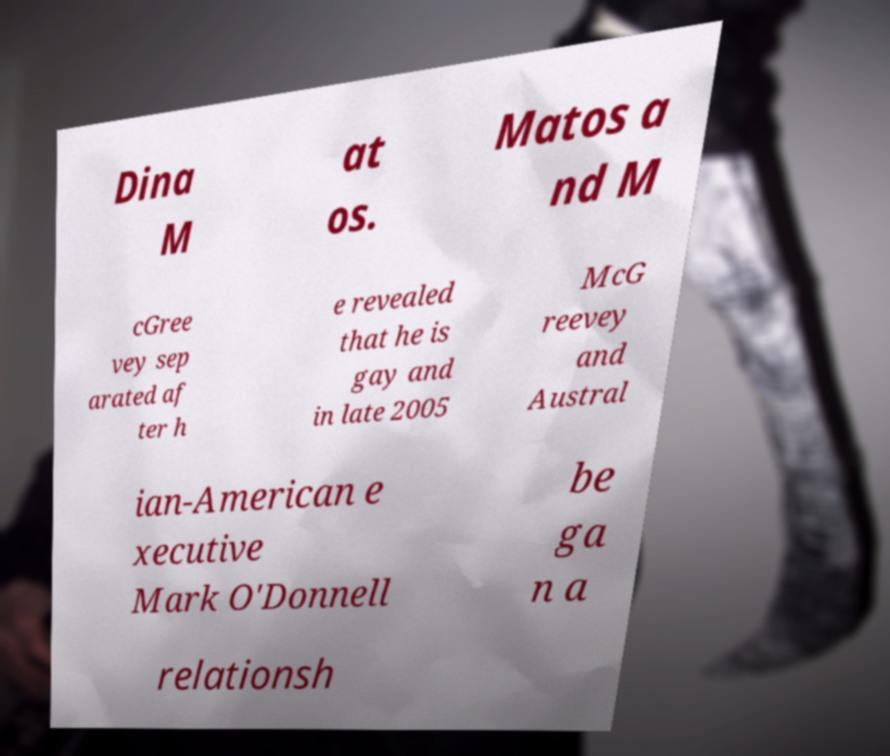Please read and relay the text visible in this image. What does it say? Dina M at os. Matos a nd M cGree vey sep arated af ter h e revealed that he is gay and in late 2005 McG reevey and Austral ian-American e xecutive Mark O'Donnell be ga n a relationsh 